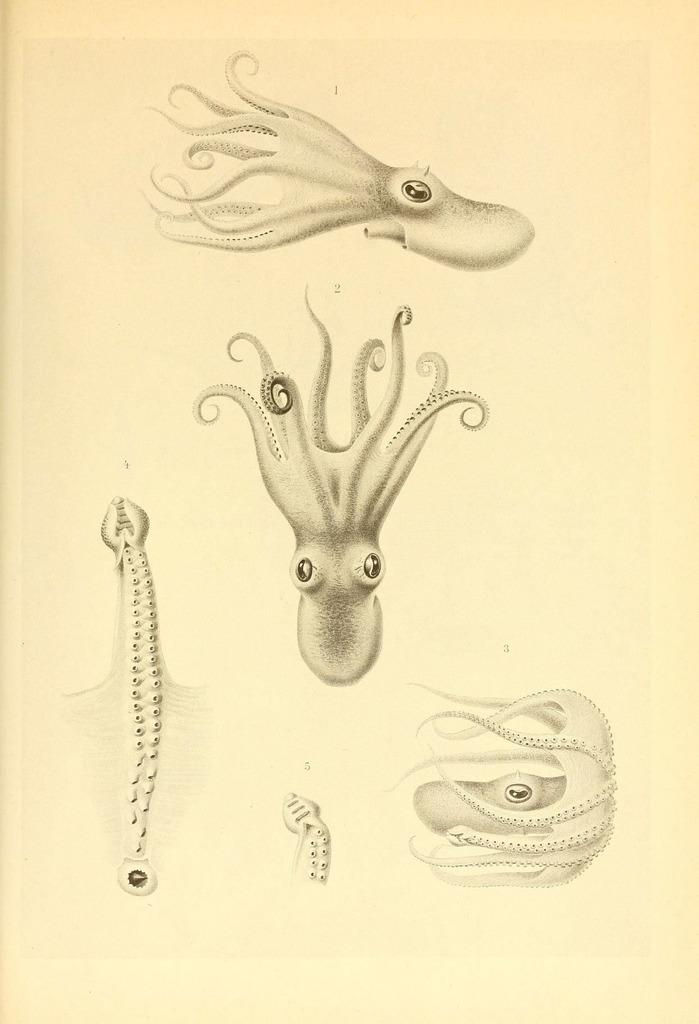What is the medium of the image? The image is on a paper. What is the main subject of the image? There is a picture of an octopus on the paper. What details about the octopus are visible in the image? The parts of the octopus are depicted in the image. What type of art can be seen in the alley behind the farm in the image? There is no alley or farm present in the image; it features a picture of an octopus on a paper. 